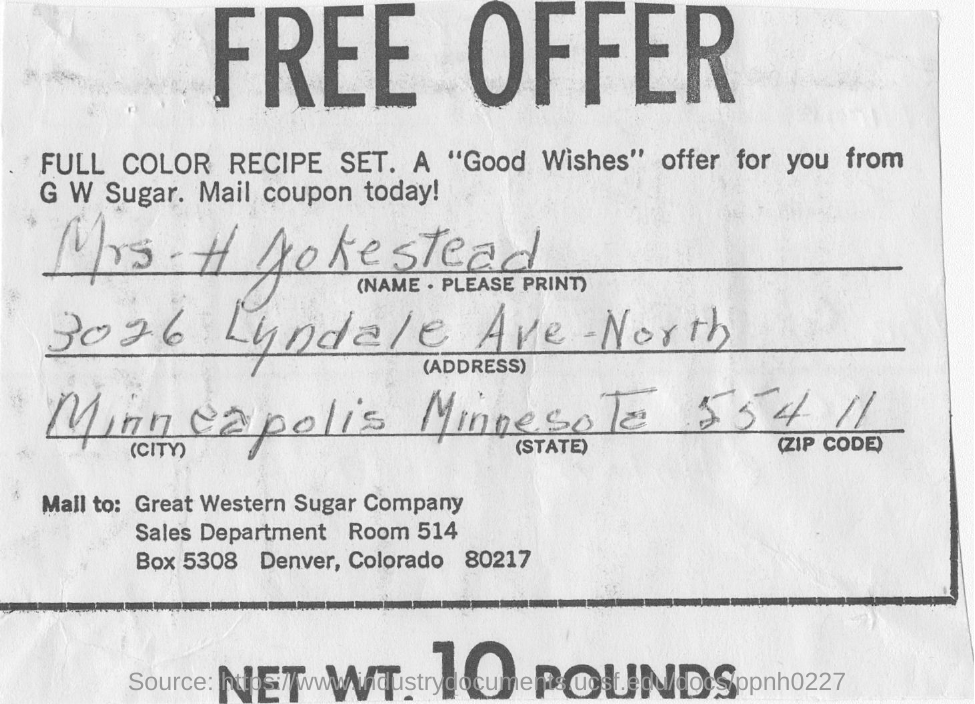Heading of the document
Your answer should be very brief. FREE OFFER. Great western sugar company sales department room number is
Keep it short and to the point. Room 514. In which city does the person who fllled the form reside?
Your response must be concise. Minneapolis. 